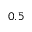<formula> <loc_0><loc_0><loc_500><loc_500>0 . 5</formula> 